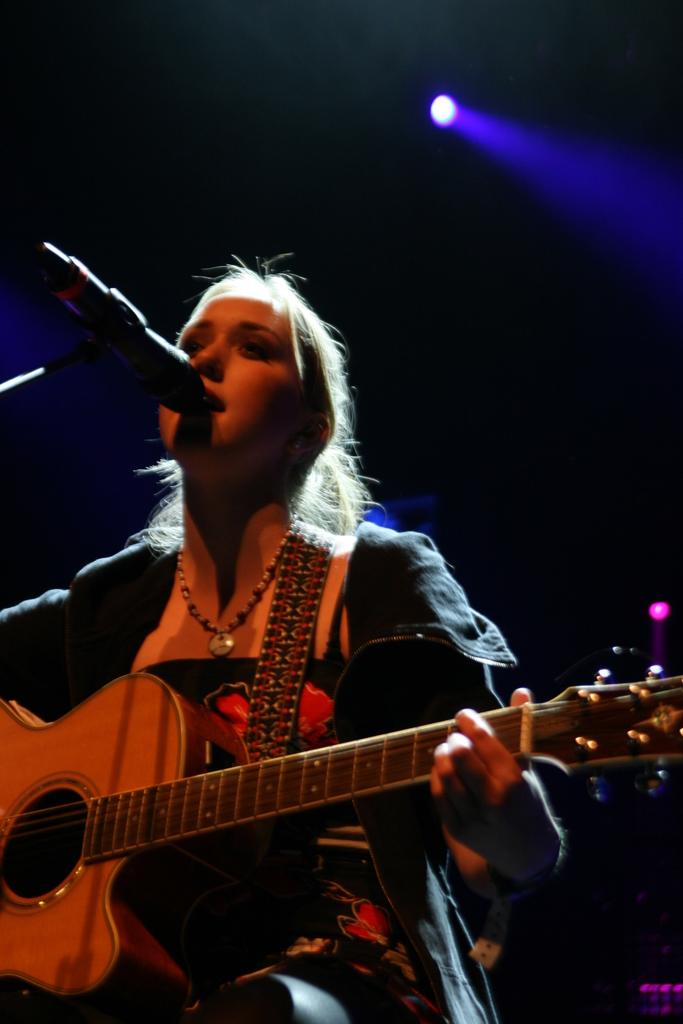Who is the main subject in the image? There is a lady in the image. What is the lady wearing? The lady is wearing a black dress. What is the lady holding in the image? The lady is holding a guitar. What is the lady doing with the guitar? The lady is playing the guitar. What is the lady standing in front of? The lady is standing in front of a microphone. What color is the light behind the lady? There is a blue light behind the lady. What type of drink is the lady holding in the image? There is no drink visible in the image; the lady is holding a guitar. 